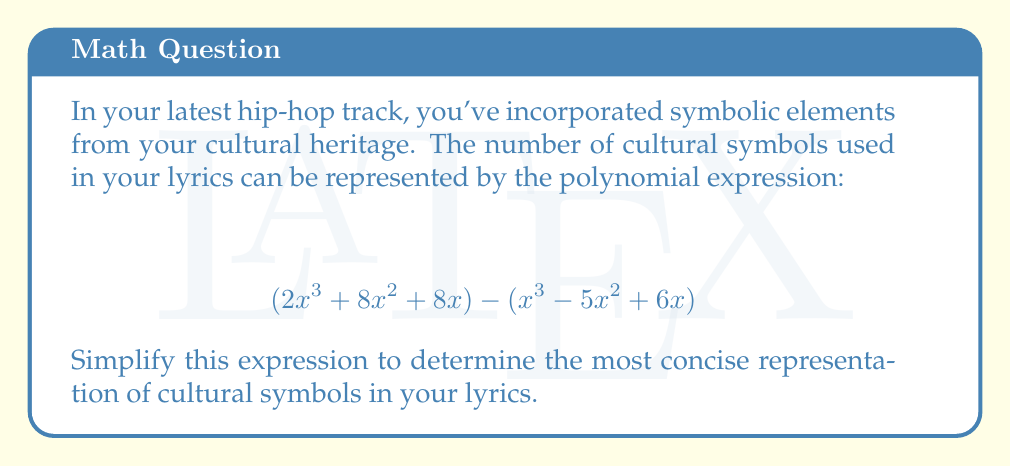Show me your answer to this math problem. Let's approach this step-by-step:

1) First, we need to identify like terms in both polynomials. We have:
   - $x^3$ terms
   - $x^2$ terms
   - $x$ terms

2) Now, let's subtract the second polynomial from the first:

   $$(2x^3 + 8x^2 + 8x) - (x^3 - 5x^2 + 6x)$$

3) When subtracting polynomials, we subtract the coefficients of like terms:

   - For $x^3$: $2x^3 - x^3 = x^3$
   - For $x^2$: $8x^2 - (-5x^2) = 8x^2 + 5x^2 = 13x^2$
   - For $x$: $8x - 6x = 2x$

4) Now we can write our simplified polynomial:

   $$x^3 + 13x^2 + 2x$$

5) This polynomial is already in its simplest form as there are no like terms to combine further.
Answer: $$x^3 + 13x^2 + 2x$$ 